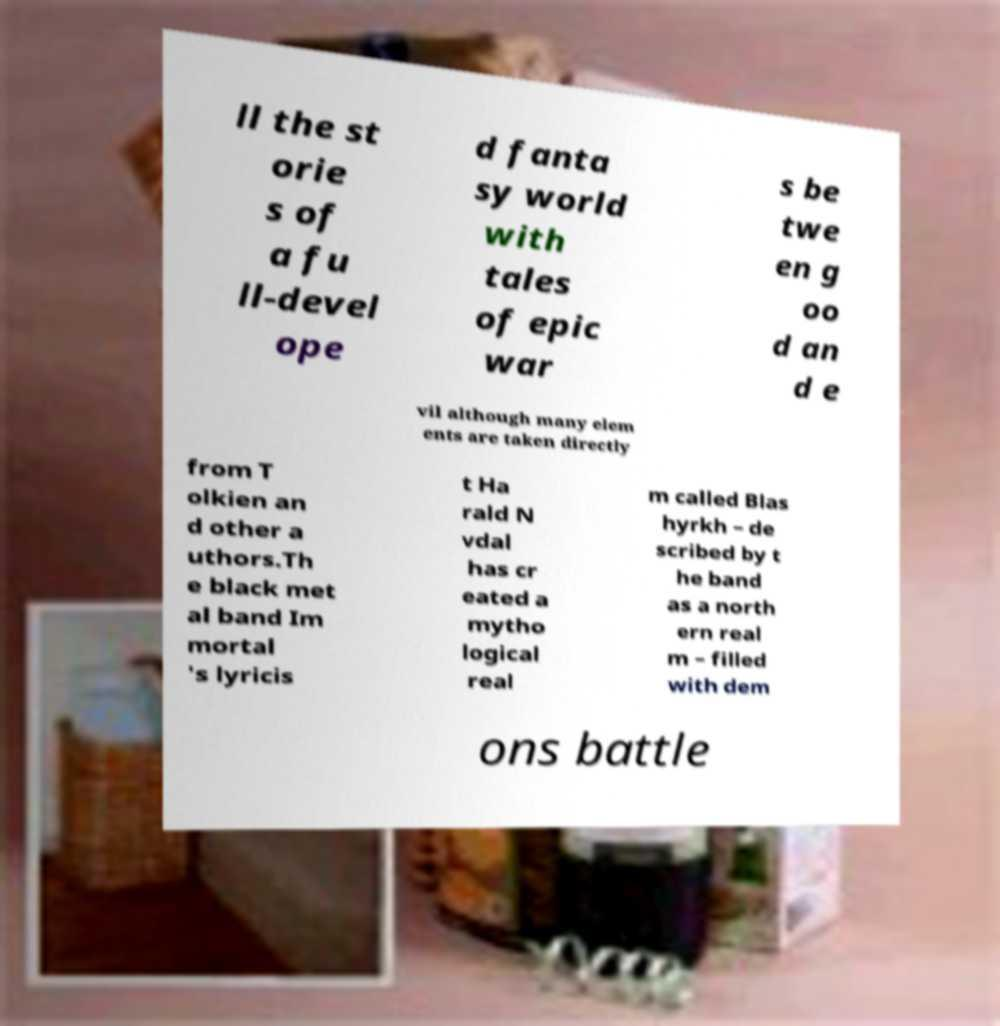What messages or text are displayed in this image? I need them in a readable, typed format. ll the st orie s of a fu ll-devel ope d fanta sy world with tales of epic war s be twe en g oo d an d e vil although many elem ents are taken directly from T olkien an d other a uthors.Th e black met al band Im mortal 's lyricis t Ha rald N vdal has cr eated a mytho logical real m called Blas hyrkh – de scribed by t he band as a north ern real m – filled with dem ons battle 